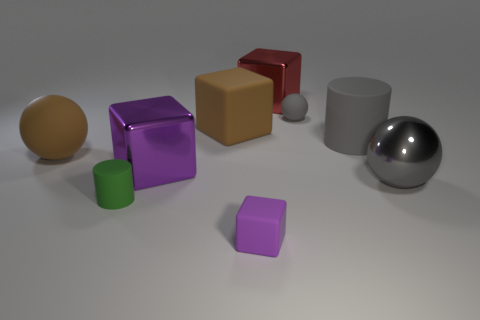Is the number of large metal blocks that are in front of the small matte sphere less than the number of spheres?
Offer a very short reply. Yes. What number of other objects are the same material as the tiny gray ball?
Your answer should be compact. 5. Is the size of the gray cylinder the same as the purple shiny object?
Offer a very short reply. Yes. How many things are either big rubber objects to the right of the big matte sphere or red metallic objects?
Your answer should be compact. 3. What material is the cylinder right of the large brown matte cube that is behind the big shiny sphere?
Offer a terse response. Rubber. Are there any purple things that have the same shape as the red metallic thing?
Your response must be concise. Yes. Is the size of the red shiny object the same as the shiny thing that is on the left side of the brown matte block?
Provide a short and direct response. Yes. How many things are either tiny things in front of the green object or matte objects right of the tiny purple rubber cube?
Keep it short and to the point. 3. Is the number of small gray objects that are to the right of the tiny green object greater than the number of small purple cylinders?
Offer a terse response. Yes. What number of metal cubes have the same size as the green matte object?
Provide a succinct answer. 0. 